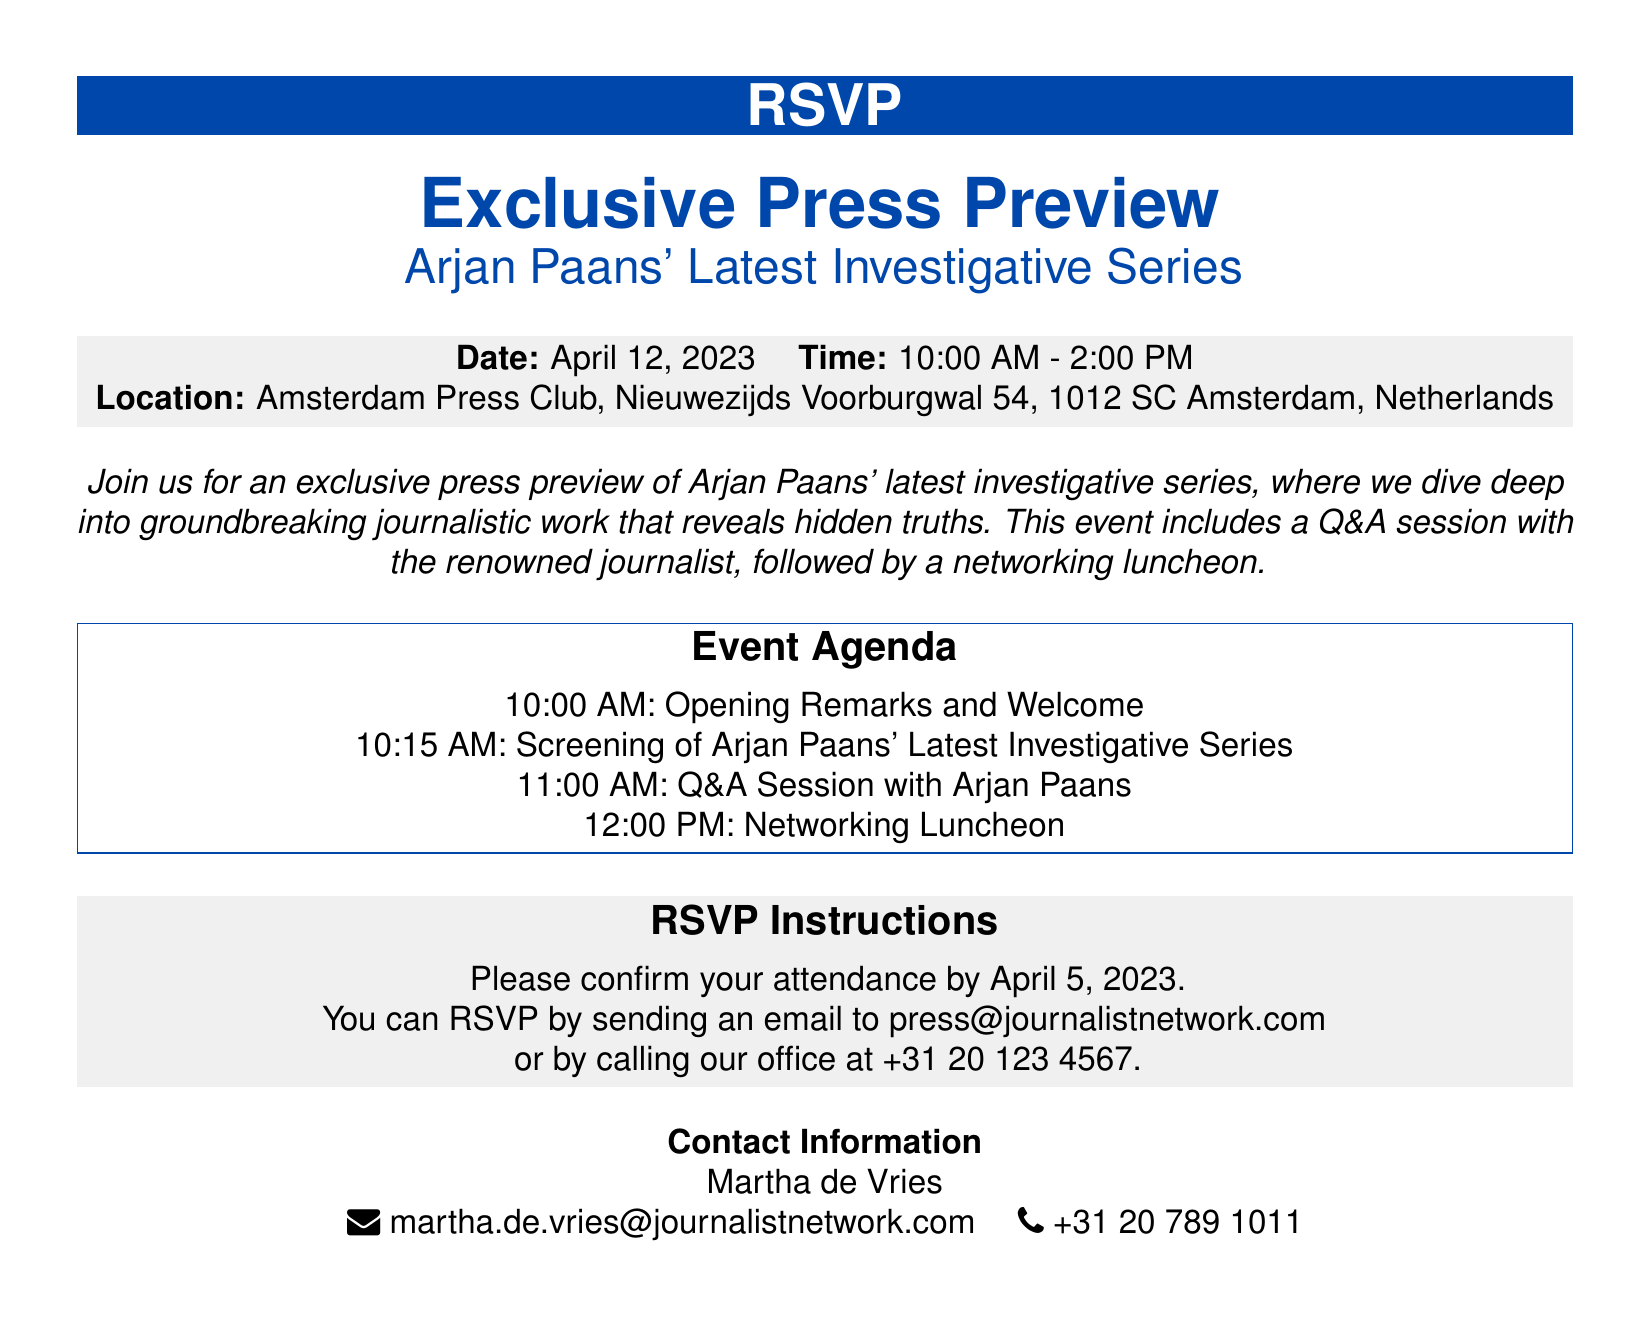What is the date of the event? The event date is explicitly mentioned in the document as April 12, 2023.
Answer: April 12, 2023 What time does the event start? The event start time is stated in the document, which is 10:00 AM.
Answer: 10:00 AM Where is the event located? The location of the event is detailed in the document, specifying Amsterdam Press Club, Nieuwezijds Voorburgwal 54, 1012 SC Amsterdam, Netherlands.
Answer: Amsterdam Press Club Who is the journalist presenting at the event? The document names Arjan Paans as the journalist presenting his latest investigative series.
Answer: Arjan Paans What is included in the event agenda after the screening? The event agenda stated in the document indicates that there will be a Q&A session with Arjan Paans following the screening.
Answer: Q&A session What is the deadline to RSVP? The RSVP instructions in the document specify that the deadline to confirm attendance is April 5, 2023.
Answer: April 5, 2023 How can attendees RSVP for the event? The document outlines the ways to RSVP, including sending an email or calling the office.
Answer: Email or phone What is the purpose of the event? The document describes the event's purpose as an exclusive preview of Arjan Paans' latest investigative series, focused on revealing hidden truths.
Answer: Exclusive press preview Who should attendees contact for more information? The contact information provided in the document indicates that attendees should reach out to Martha de Vries for further inquiries.
Answer: Martha de Vries 